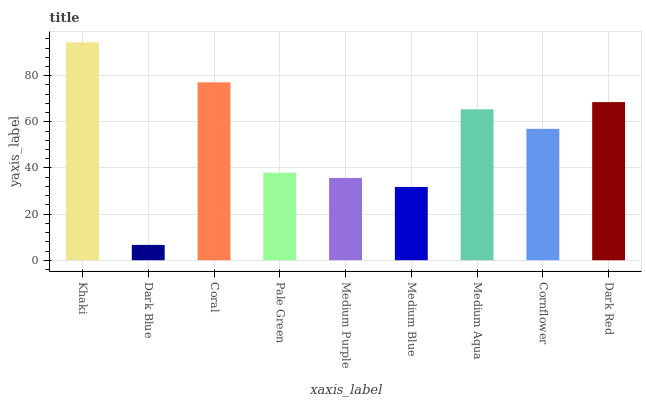Is Dark Blue the minimum?
Answer yes or no. Yes. Is Khaki the maximum?
Answer yes or no. Yes. Is Coral the minimum?
Answer yes or no. No. Is Coral the maximum?
Answer yes or no. No. Is Coral greater than Dark Blue?
Answer yes or no. Yes. Is Dark Blue less than Coral?
Answer yes or no. Yes. Is Dark Blue greater than Coral?
Answer yes or no. No. Is Coral less than Dark Blue?
Answer yes or no. No. Is Cornflower the high median?
Answer yes or no. Yes. Is Cornflower the low median?
Answer yes or no. Yes. Is Medium Aqua the high median?
Answer yes or no. No. Is Dark Red the low median?
Answer yes or no. No. 